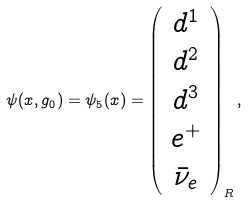Convert formula to latex. <formula><loc_0><loc_0><loc_500><loc_500>\psi ( x , g _ { 0 } ) = \psi _ { 5 } ( x ) = \left ( \begin{array} { c } d ^ { 1 } \\ d ^ { 2 } \\ d ^ { 3 } \\ e ^ { + } \\ \bar { \nu } _ { e } \end{array} \right ) _ { R } ,</formula> 